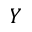<formula> <loc_0><loc_0><loc_500><loc_500>Y</formula> 